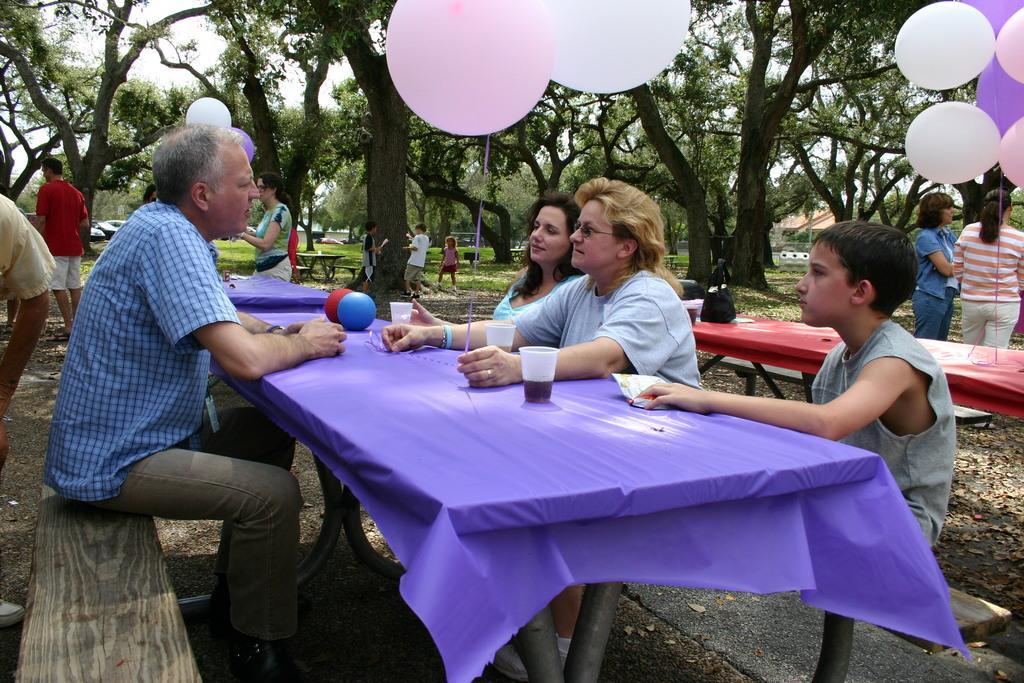Please provide a concise description of this image. In this image i can see there are group of people who are sitting on a bench in front of a table. I can see there are few trees and few balloons. 